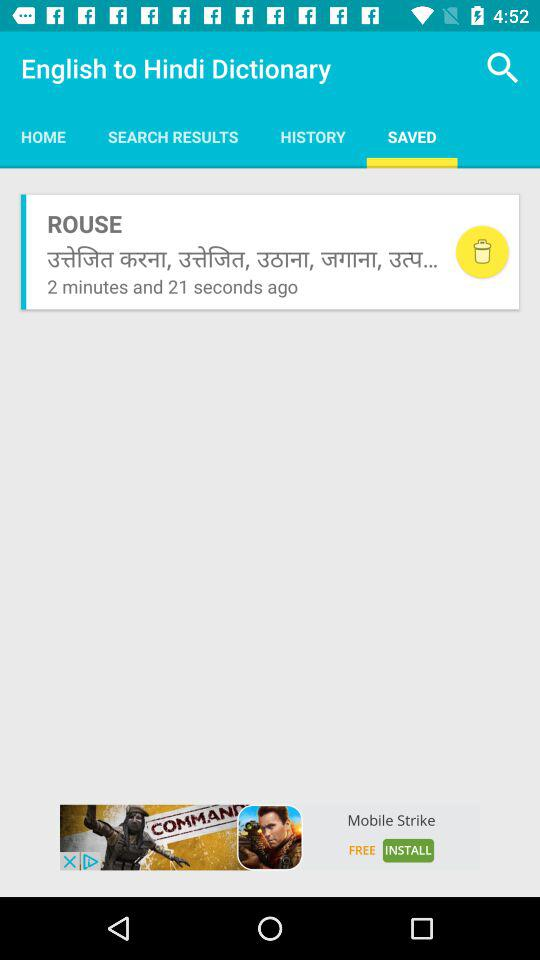Which tab is selected? The selected tab is "Saved". 